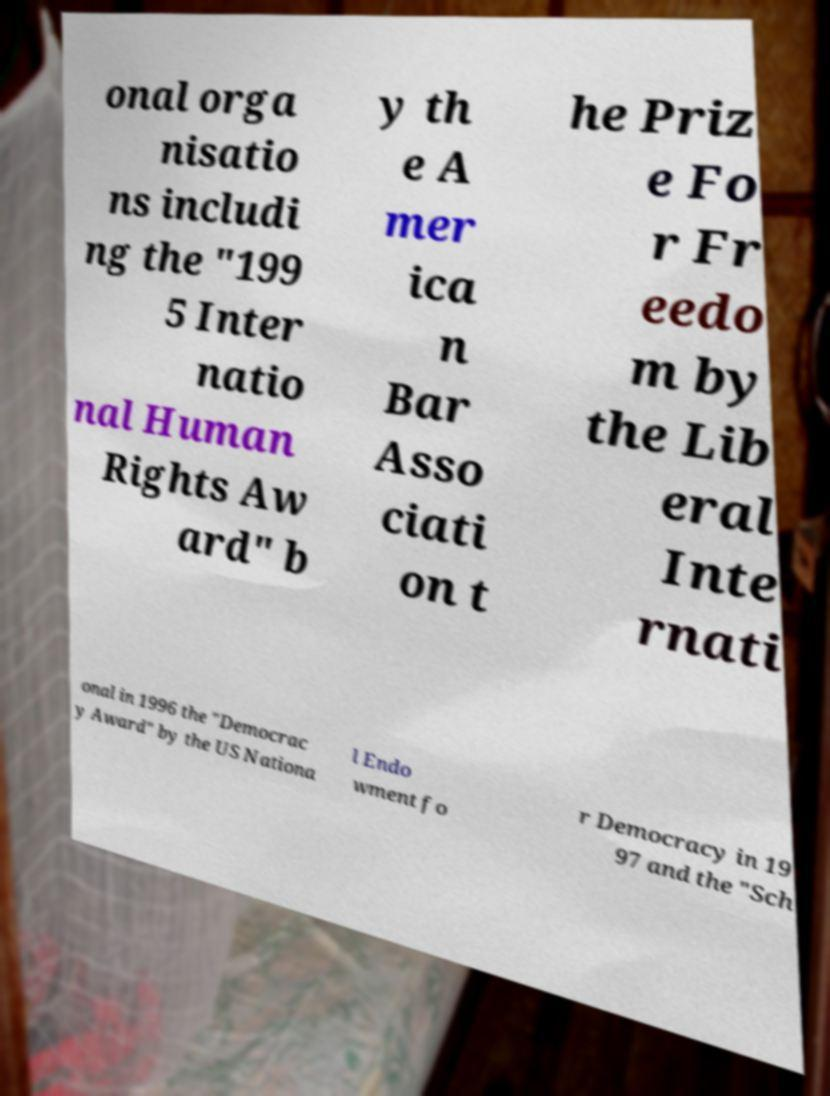Can you read and provide the text displayed in the image?This photo seems to have some interesting text. Can you extract and type it out for me? onal orga nisatio ns includi ng the "199 5 Inter natio nal Human Rights Aw ard" b y th e A mer ica n Bar Asso ciati on t he Priz e Fo r Fr eedo m by the Lib eral Inte rnati onal in 1996 the "Democrac y Award" by the US Nationa l Endo wment fo r Democracy in 19 97 and the "Sch 